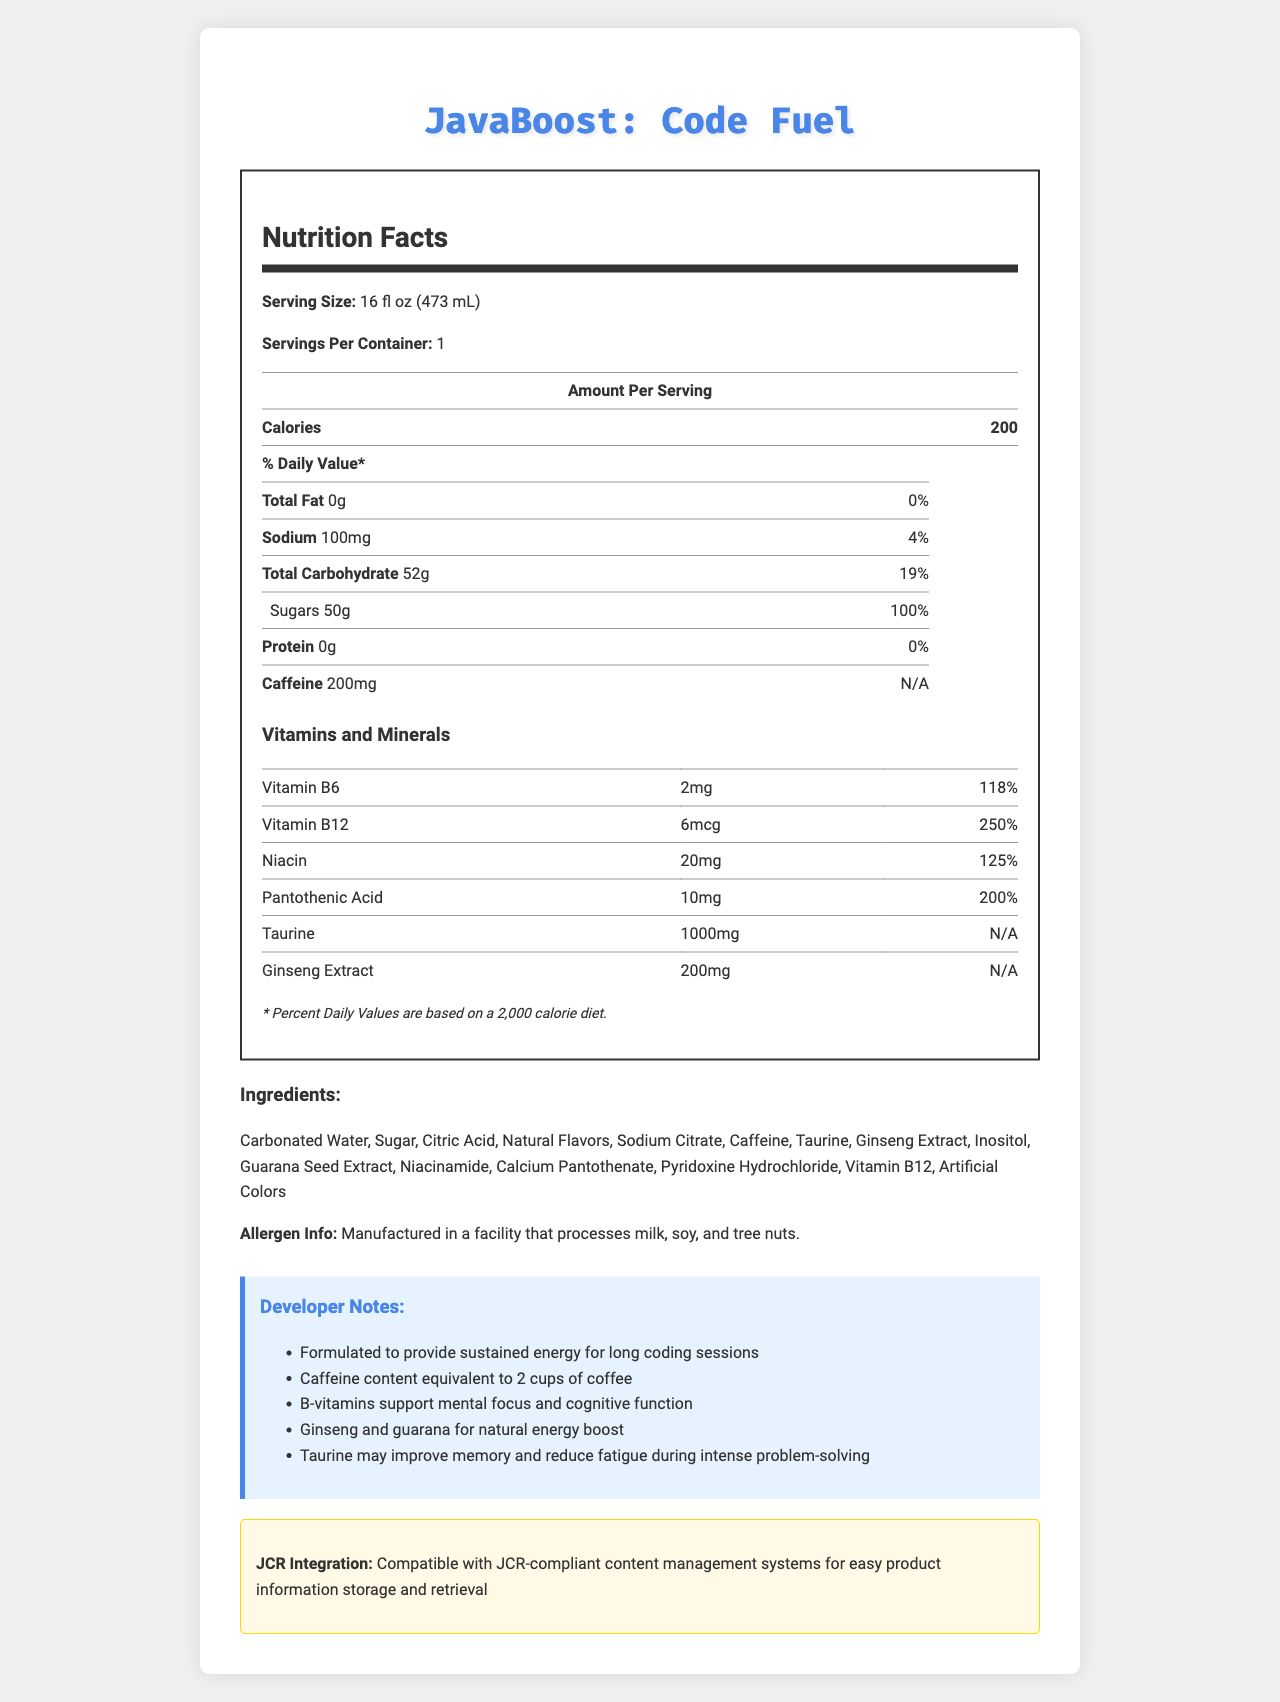what is the serving size of JavaBoost: Code Fuel? The serving size is directly stated near the top of the nutrition label section of the document.
Answer: 16 fl oz (473 mL) how many calories are there per serving? The calorie count per serving is listed as 200 in the nutrition facts table.
Answer: 200 what is the amount of caffeine in the drink? The caffeine content is clearly indicated as 200mg in the nutrition facts table.
Answer: 200mg how much sodium is in one serving? The sodium content is given as 100mg per serving in the nutrition facts table.
Answer: 100mg which vitamin has the highest daily value percentage? Vitamin B12 has a daily value percentage of 250%, which is the highest among the listed vitamins and minerals.
Answer: Vitamin B12 what is the amount of sugars per serving? A. 45g B. 50g C. 52g D. 100g The document states that there are 50g of sugars per serving.
Answer: B which ingredient is listed first? A. Sugar B. Carbonated Water C. Caffeine The first ingredient listed is Carbonated Water.
Answer: B does JavaBoost: Code Fuel contain any protein? The nutrition facts table marks the protein content as 0g, indicating no protein in the drink.
Answer: No is the drink manufactured in a facility that processes any allergens? The allergen info states that the drink is manufactured in a facility that processes milk, soy, and tree nuts.
Answer: Yes summarize the main idea of the document. The document covers various details such as serving size, calorie content, amounts of specific nutrients like fat, sodium, carbohydrates, sugars, protein, and caffeine, as well as vitamins and minerals. It also lists ingredients, allergen information, developer notes about the product’s benefits, and the compatibility with JCR-compliant systems.
Answer: The document provides the nutritional information for the JavaBoost: Code Fuel energy drink, highlighting its caffeine content, vitamins, and ingredients, along with special notes for developers and details about JCR integration. what is the exact amount of taurine in the drink? The amount of taurine is listed as 1000mg in the vitamins and minerals section.
Answer: 1000mg what is the main purpose of the developer notes section? A. To provide allergen information B. To list calories and nutrients C. To describe special features and benefits for developers D. To list ingredients The developer notes are meant to describe special features and benefits for developers, such as sustained energy for coding and cognitive support.
Answer: C how many vitamins and minerals are listed in the document? The document lists 6 vitamins and minerals: Vitamin B6, Vitamin B12, Niacin, Pantothenic Acid, Taurine, and Ginseng Extract.
Answer: 6 what is the daily value percentage of niacin present in the drink? The daily value percentage for niacin is listed as 125%.
Answer: 125% does the drink contain artificial colors? Artificial Colors are included in the list of ingredients.
Answer: Yes how much inositol is in the drink? The document lists inositol among the ingredients, but it does not specify the amount.
Answer: Not enough information 